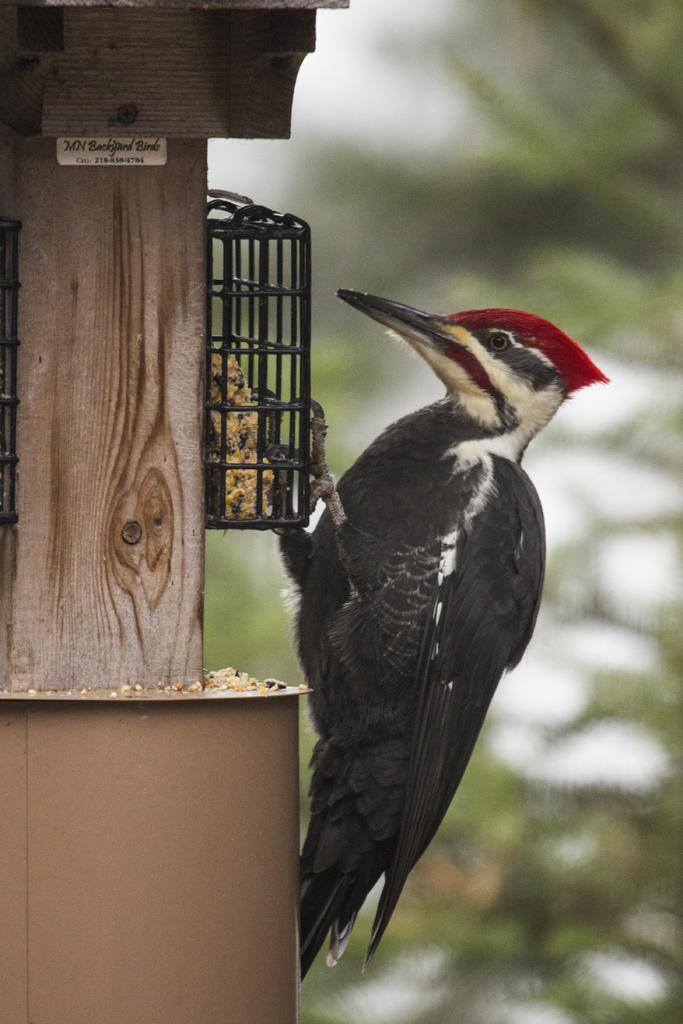What type of bird is in the image? There is a woodpecker bird in the image. Where is the bird located? The bird is on a stand. What is the stand attached to? The stand is attached to a wooden pole. Is there any writing on the wooden pole? Yes, there is a wooden pole with writing on it in the image. How would you describe the background of the image? The background of the image is blurred. How many snakes are wrapped around the wooden pole in the image? There are no snakes present in the image; it features a woodpecker bird on a stand attached to a wooden pole with writing on it. What type of health advice can be seen on the wooden pole in the image? There is no health advice visible on the wooden pole in the image; it only has writing on it. 